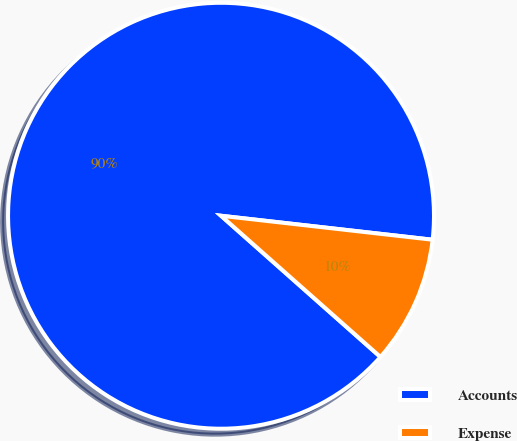Convert chart to OTSL. <chart><loc_0><loc_0><loc_500><loc_500><pie_chart><fcel>Accounts<fcel>Expense<nl><fcel>90.26%<fcel>9.74%<nl></chart> 